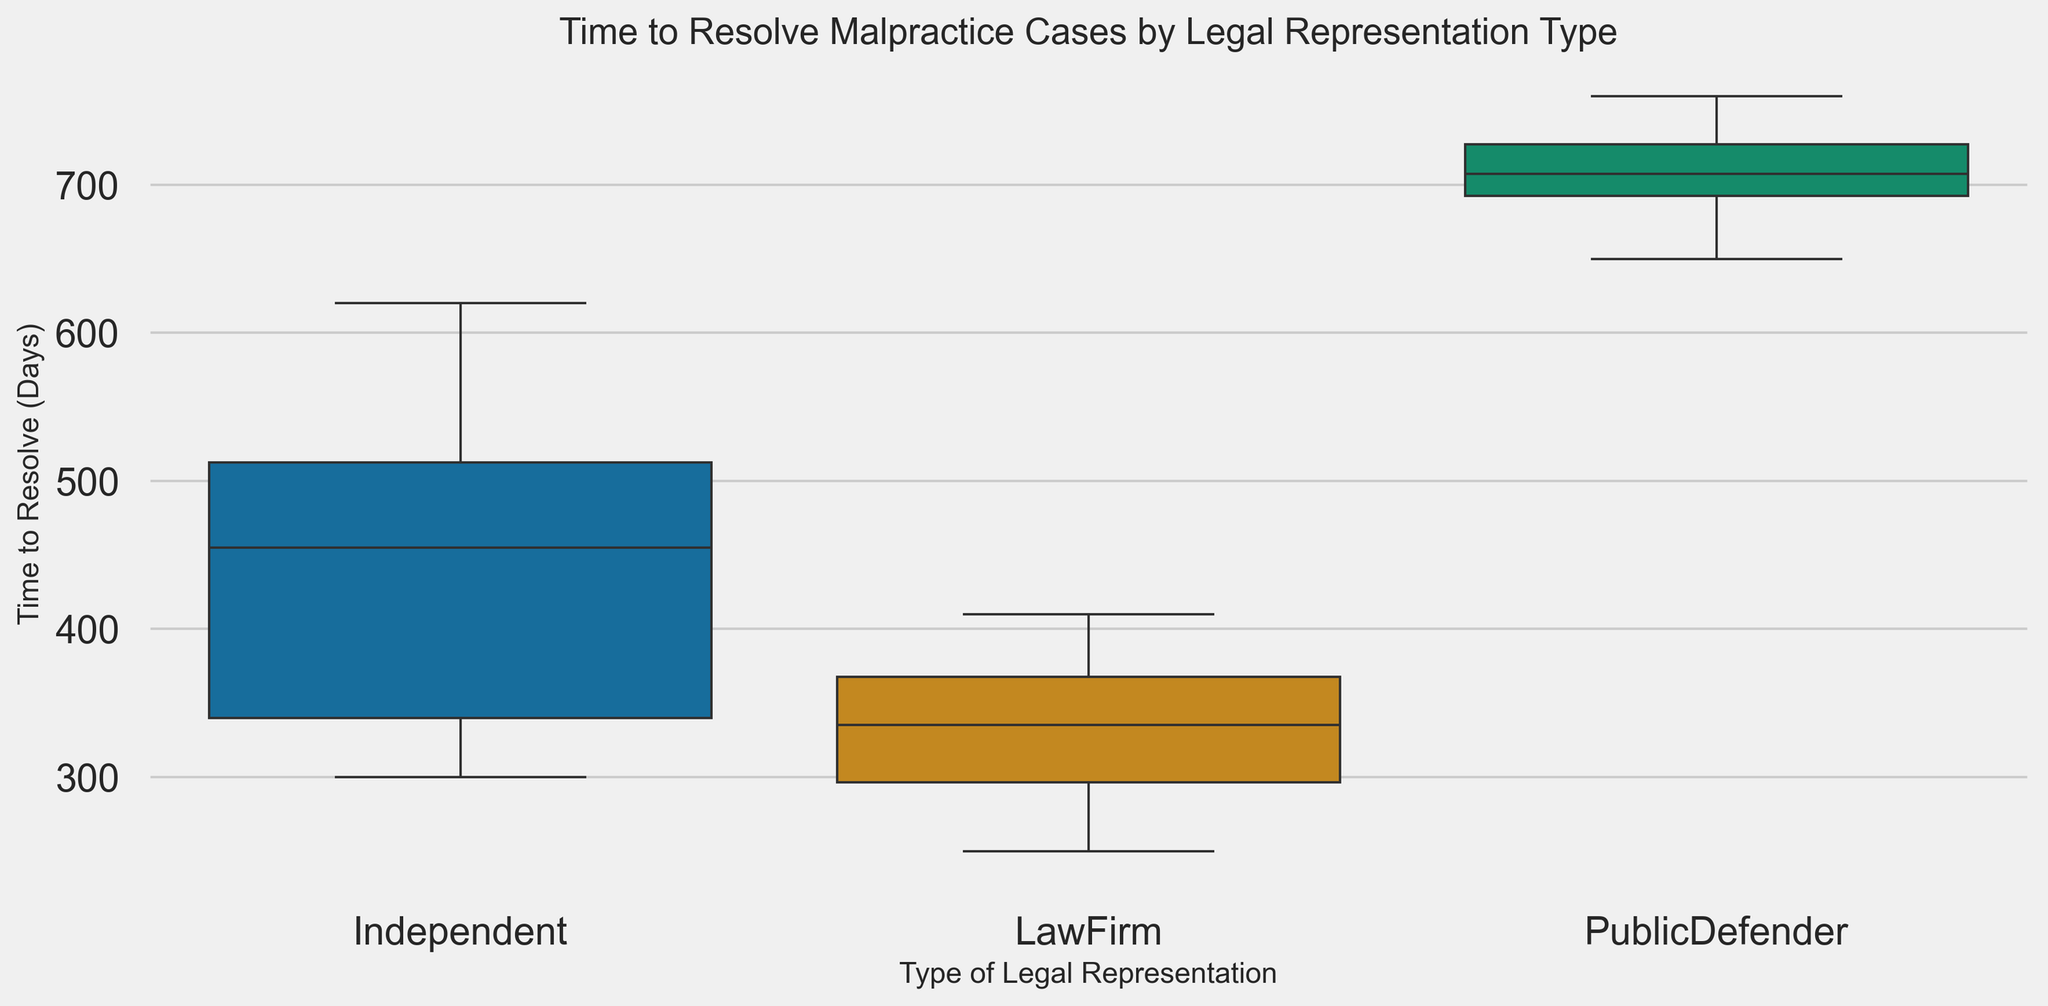What is the median time to resolve malpractice cases for each type of legal representation? To find the median time for each group, we look at the line inside each box in the box plot. This line represents the median. For Independent representation, the median appears around 450 days. For Law Firm representation, the median is approximately 330 days. Lastly, Public Defender representation shows a median around 705 days.
Answer: Independent: 450 days, Law Firm: 330 days, Public Defender: 705 days Which type of legal representation has the widest range of resolution times? To determine the range, we look at the difference between the upper and lower whiskers of each box plot. The widest range belongs to Public Defender representation, which spans from around 650 days to 760 days.
Answer: Public Defender How does the interquartile range (IQR) of Independent representations compare to Law Firm representations? The IQR is the range between the first quartile (bottom of the box) and the third quartile (top of the box). For Independent, the IQR is from approximately 320 to 520 days, resulting in a 200-day IQR. For Law Firm, the IQR spans from approximately 290 to 370 days, resulting in an 80-day IQR.
Answer: Independent: 200 days, Law Firm: 80 days What is the maximum time to resolve a case for Law Firm representation? The maximum is identified by the upper whisker or any points beyond it. For Law Firm representation, the upper whisker extends to about 410 days, indicating this as the maximum.
Answer: 410 days Which type of legal representation has the smallest median resolution time, and by how much is it smaller than the other two types? Comparing the median times, Law Firm representation has the smallest median at 330 days. It is smaller than Independent by 120 days (450 - 330) and smaller than Public Defender by 375 days (705 - 330).
Answer: Law Firm is 120 days smaller than Independent and 375 days smaller than Public Defender Are there any overlapping ranges of time to resolve cases between any two types of legal representation? To find overlapping ranges, we compare the whiskers and boxes of each group. There is some overlap between Independent and Law Firm representations, noting that the upper whisker of Law Firm (410 days) intersects with the lower part of the Independent range (320 days). There is no overlap between Public Defender and the other two groups.
Answer: Yes, between Independent and Law Firm What are the minimum time values for each type of legal representation? The minimum times are noted at the lower whisker of each box plot. For Independent, it is around 300 days. For Law Firm, it is approximately 250 days. For Public Defender, it is around 650 days.
Answer: Independent: 300 days, Law Firm: 250 days, Public Defender: 650 days Which group shows the most variation in the time to resolve cases, and what might be a visible indicator of this in the plot? Most variation is often indicated by a taller box and longer whiskers. Public Defender representation shows the most variation, as indicated by its taller box and longer whiskers compared to Independent and Law Firm representations.
Answer: Public Defender 